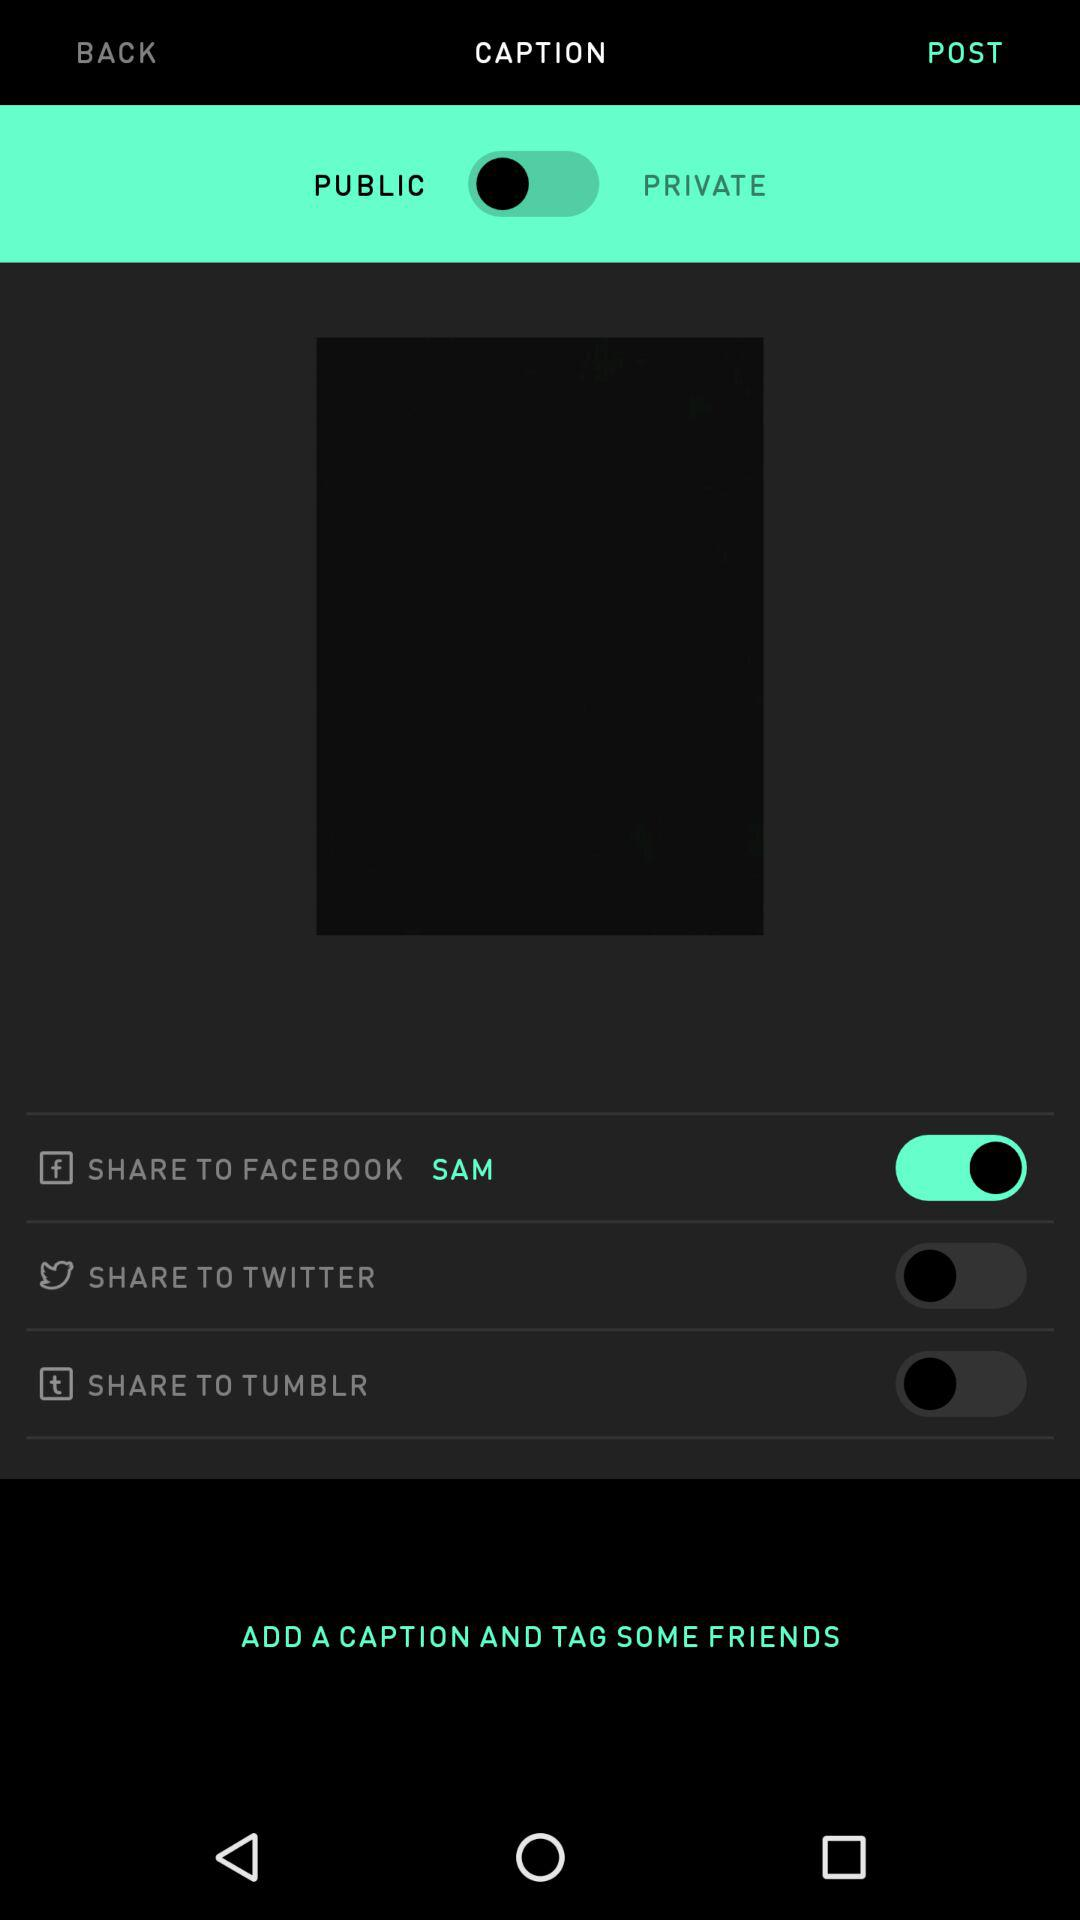What is the status of the "SHARE TO FACEBOOK" button? The status of the "SHARE TO FACEBOOK" button is "on". 